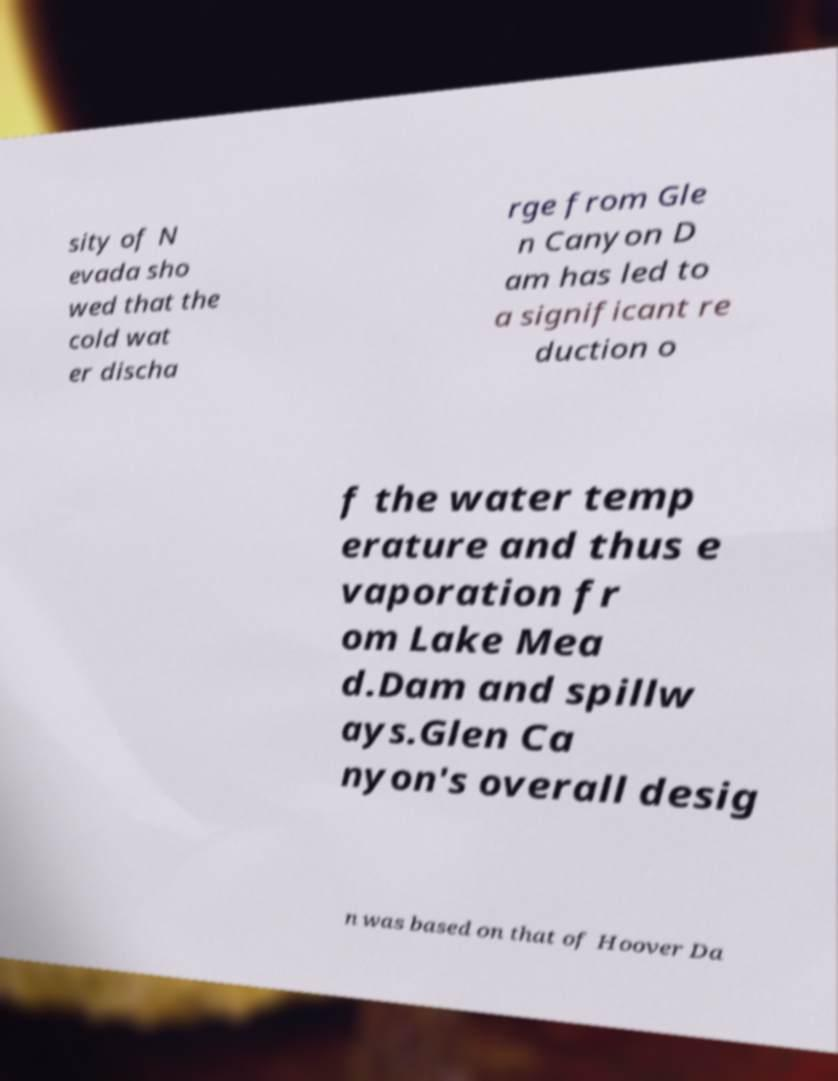I need the written content from this picture converted into text. Can you do that? sity of N evada sho wed that the cold wat er discha rge from Gle n Canyon D am has led to a significant re duction o f the water temp erature and thus e vaporation fr om Lake Mea d.Dam and spillw ays.Glen Ca nyon's overall desig n was based on that of Hoover Da 